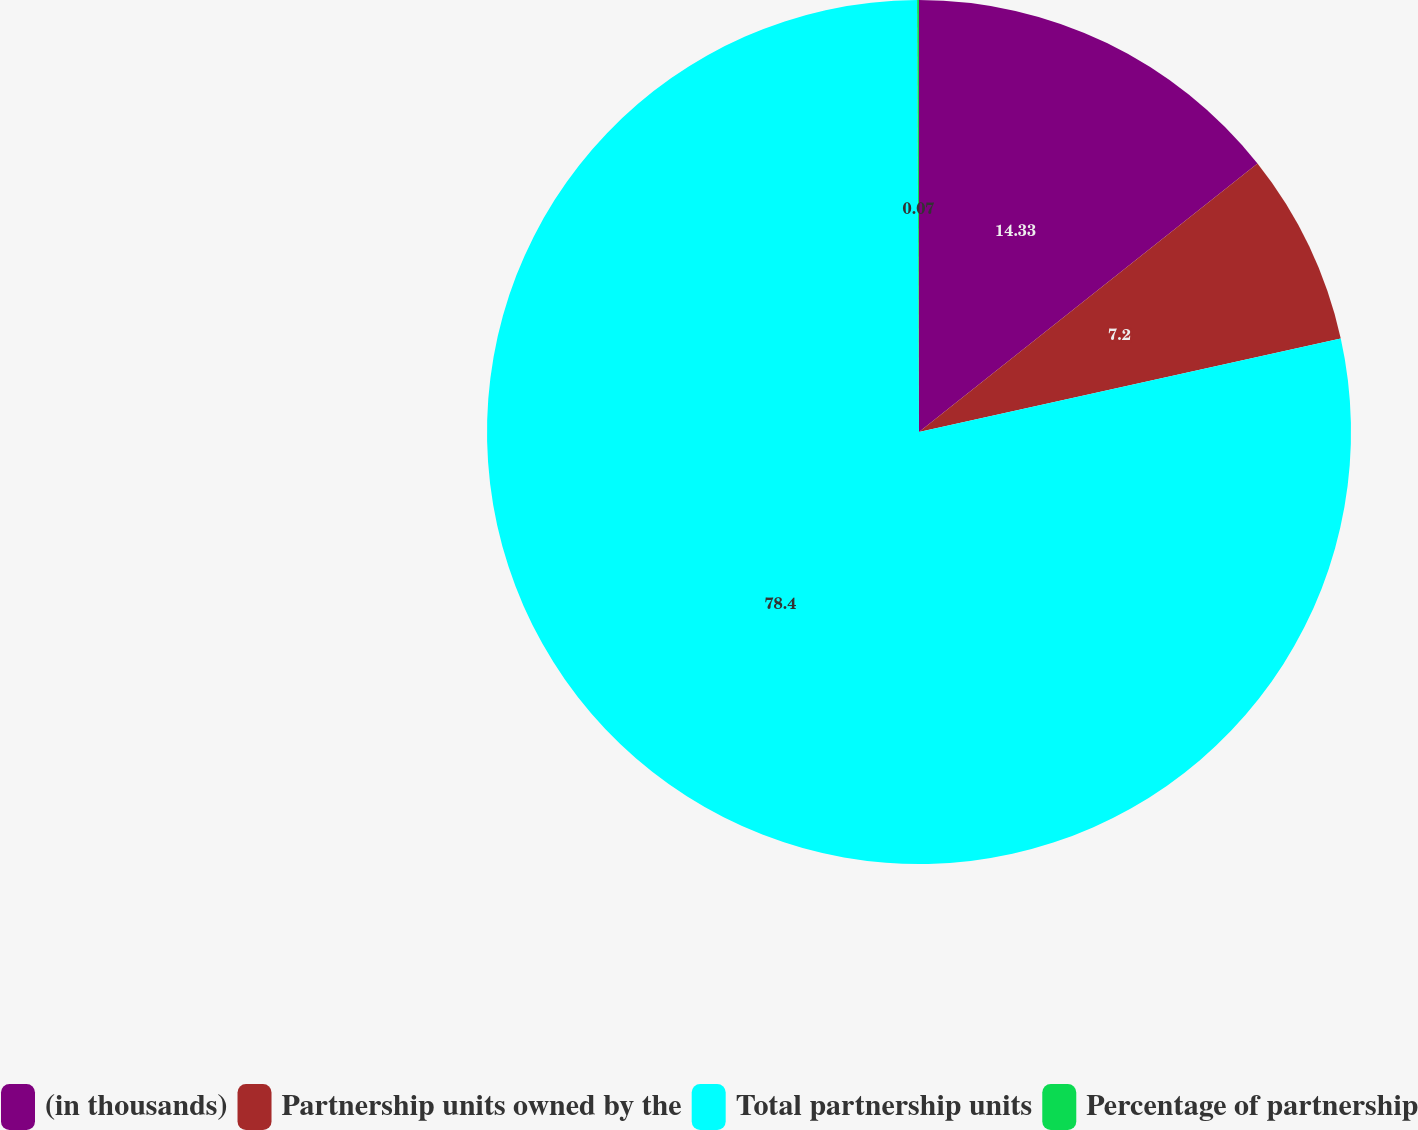Convert chart to OTSL. <chart><loc_0><loc_0><loc_500><loc_500><pie_chart><fcel>(in thousands)<fcel>Partnership units owned by the<fcel>Total partnership units<fcel>Percentage of partnership<nl><fcel>14.33%<fcel>7.2%<fcel>78.4%<fcel>0.07%<nl></chart> 